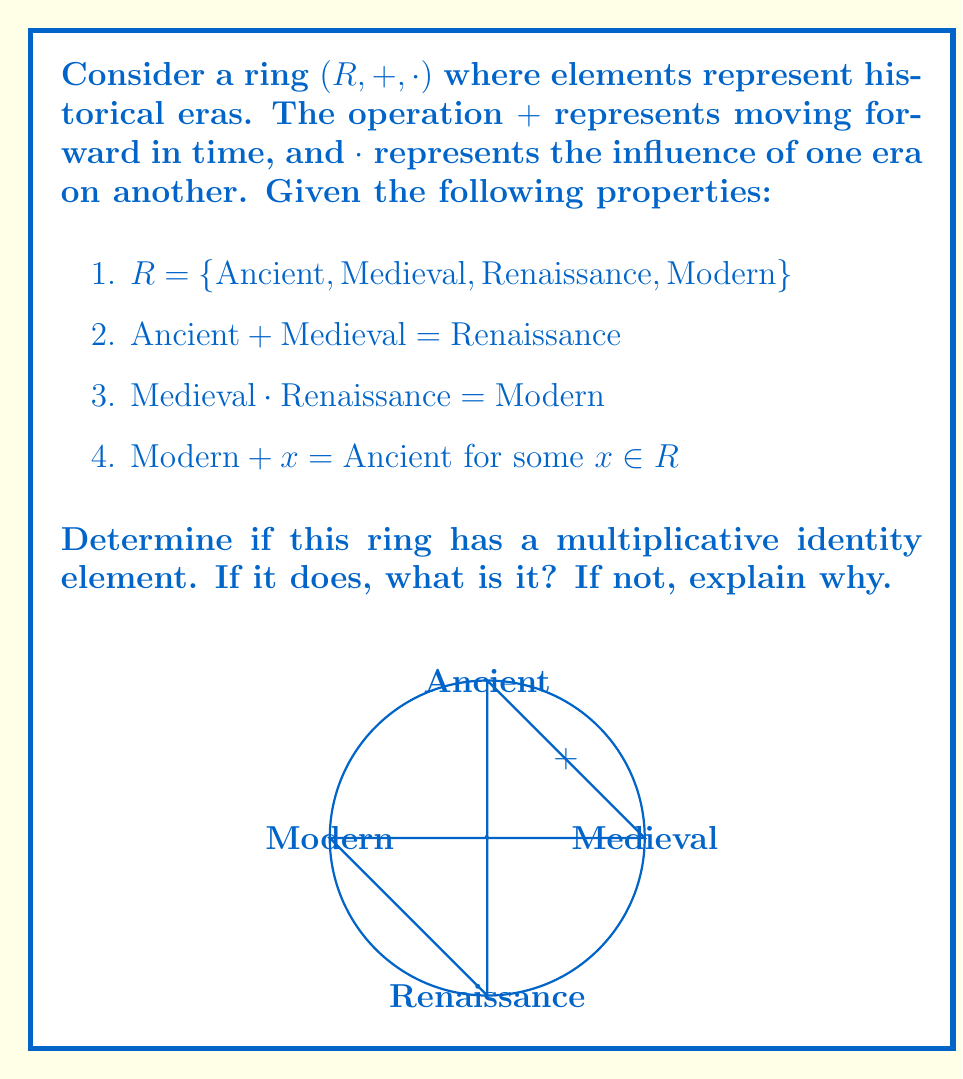Could you help me with this problem? To determine if this ring has a multiplicative identity element, we need to check if there exists an element $e \in R$ such that $e \cdot a = a \cdot e = a$ for all $a \in R$.

Let's analyze each element:

1. Ancient:
   If Ancient were the identity, we would need $\text{Ancient} \cdot \text{Medieval} = \text{Medieval}$. However, we don't have enough information to confirm or deny this.

2. Medieval:
   We know $\text{Medieval} \cdot \text{Renaissance} = \text{Modern}$, so Medieval cannot be the identity element.

3. Renaissance:
   Similar to Ancient, we lack information to determine if Renaissance could be the identity.

4. Modern:
   We know $\text{Modern} + x = \text{Ancient}$ for some $x$. This implies that Modern is not the last element in the time sequence. If Modern were the identity, we would expect $\text{Modern} \cdot a = a$ for all $a$, which contradicts the given information about the time sequence.

Given the limited information provided, we cannot conclusively determine if there is a multiplicative identity element. We would need more details about the multiplication operation for all pairs of elements to make a definitive statement.

However, based on the historical context and the given operations, it's reasonable to assume that this ring might not have a multiplicative identity element. In historical terms, no single era consistently leaves other eras unchanged when they interact or influence each other.
Answer: Cannot be determined with given information; likely no multiplicative identity exists. 